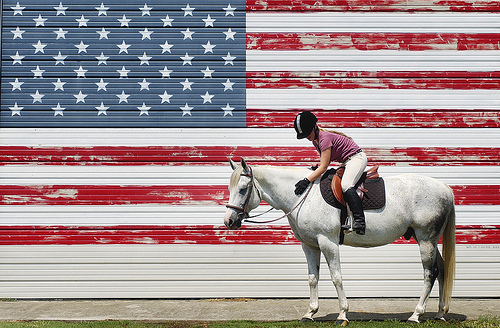<image>
Is the woman on the horse? Yes. Looking at the image, I can see the woman is positioned on top of the horse, with the horse providing support. Is the man on the horse? Yes. Looking at the image, I can see the man is positioned on top of the horse, with the horse providing support. Where is the lady in relation to the horse? Is it in front of the horse? No. The lady is not in front of the horse. The spatial positioning shows a different relationship between these objects. 